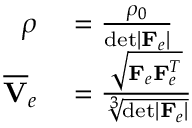Convert formula to latex. <formula><loc_0><loc_0><loc_500><loc_500>\begin{array} { r l } { \rho } & = \frac { \rho _ { 0 } } { d e t | F _ { e } | } } \\ { \overline { V } _ { e } } & = \frac { \sqrt { F _ { e } F _ { e } ^ { T } } } { \sqrt { [ } 3 ] { d e t | F _ { e } | } } } \end{array}</formula> 